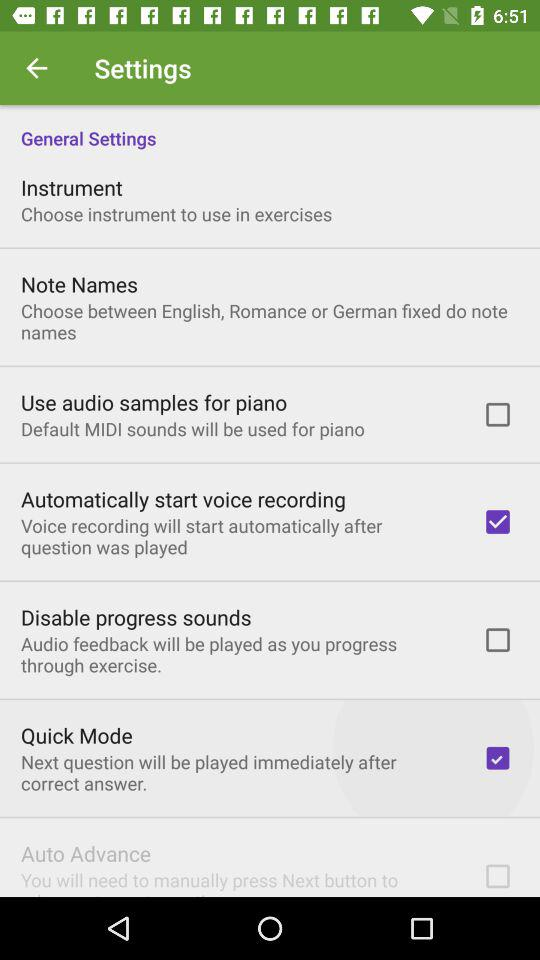Which options are marked as checked? The options are "Automatically start voice recording" and "Quick Mode". 